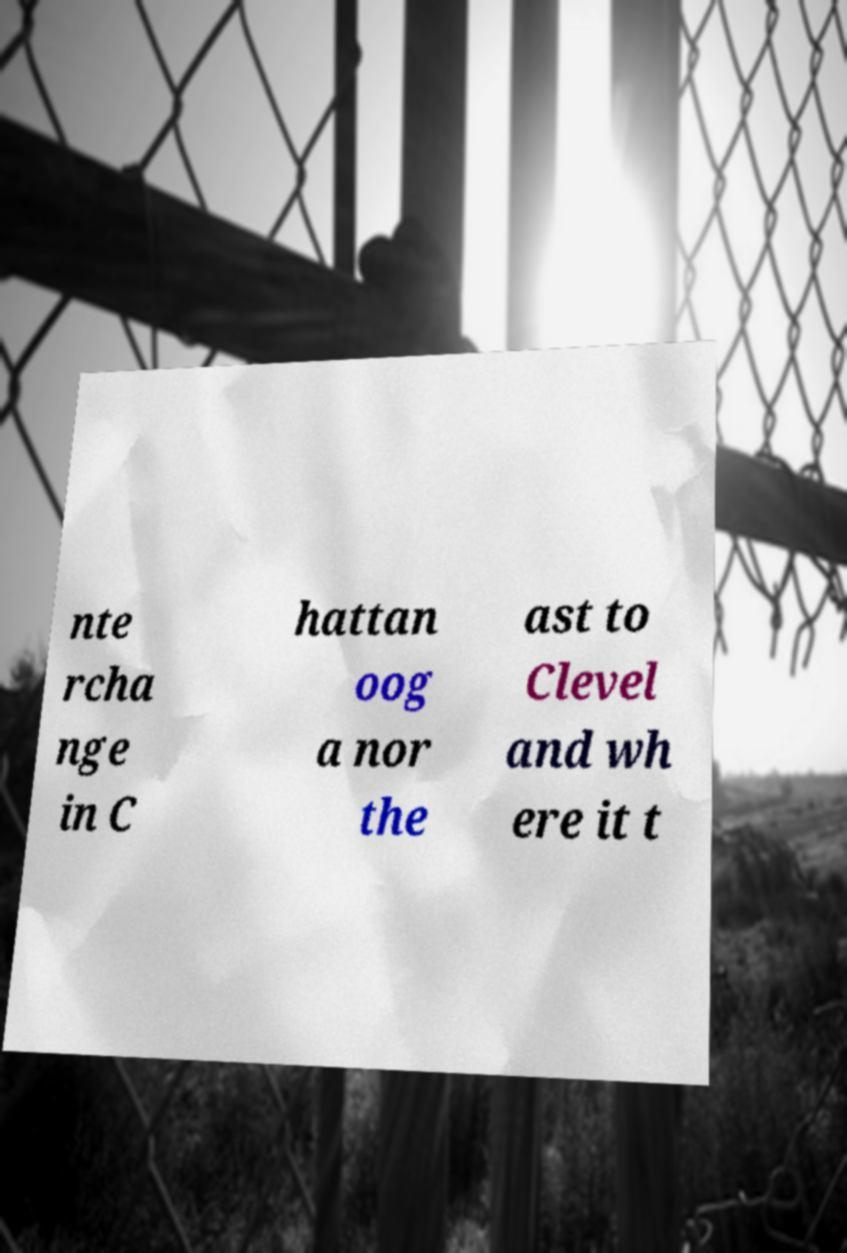There's text embedded in this image that I need extracted. Can you transcribe it verbatim? nte rcha nge in C hattan oog a nor the ast to Clevel and wh ere it t 